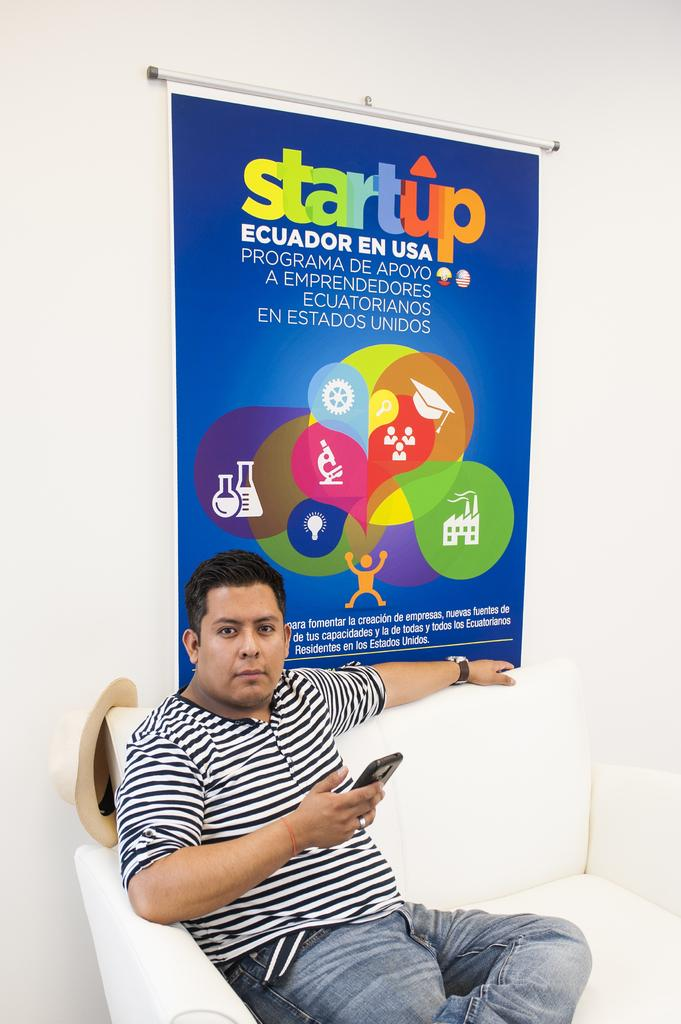What is the main subject in the foreground of the picture? There is a coach in the foreground of the picture. What else can be seen in the foreground of the picture? There is a hat and a person holding a mobile in the foreground of the picture. What is located in the middle of the picture? There is a banner in the middle of the picture. What is the color of the wall in the picture? The wall in the picture is painted white. How many babies are crawling on the coach in the picture? There are no babies present in the picture; the main subject is a coach. What type of story is being told on the banner in the picture? There is no story depicted on the banner in theanner in the picture; it is a banner without any text or images related to a story. 